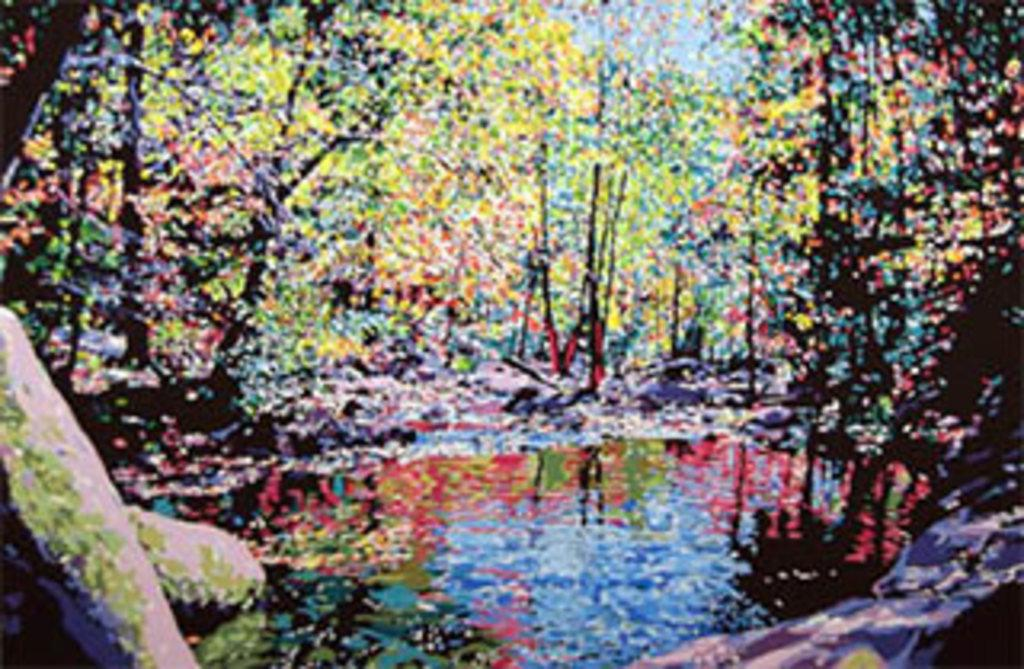What type of image is being described? The image is an edited version of a photograph. What can be seen in the image that has been altered? There are colorful trees in the image. What natural feature is present in the image? There is a water pound in the image. How many ducks are swimming in the water pound in the image? There are no ducks present in the image; it only features colorful trees and a water pound. What is the reason behind the editing of the photograph? The reason behind the editing of the photograph is not mentioned in the provided facts, so it cannot be determined from the image. 